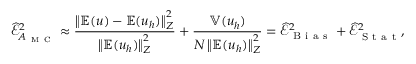<formula> <loc_0><loc_0><loc_500><loc_500>\widehat { \mathcal { E } } _ { A _ { M C } } ^ { 2 } \approx \frac { \left \| \mathbb { E } ( u ) - \mathbb { E } ( u _ { h } ) \right \| _ { Z } ^ { 2 } } { \left \| \mathbb { E } ( u _ { h } ) \right \| _ { Z } ^ { 2 } } + \frac { \mathbb { V } ( u _ { h } ) } { N \left \| \mathbb { E } ( u _ { h } ) \right \| _ { Z } ^ { 2 } } = \widehat { \mathcal { E } } _ { B i a s } ^ { 2 } + \widehat { \mathcal { E } } _ { S t a t } ^ { 2 } ,</formula> 